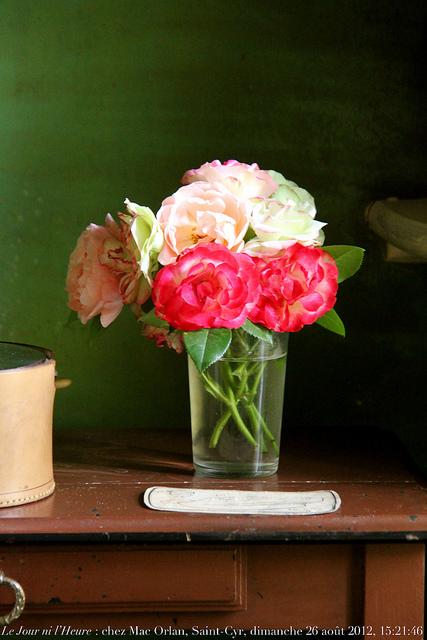Are these flowers home grown or store bought?
Concise answer only. Home grown. Are these tulips?
Write a very short answer. No. What is the vase made of?
Answer briefly. Glass. 